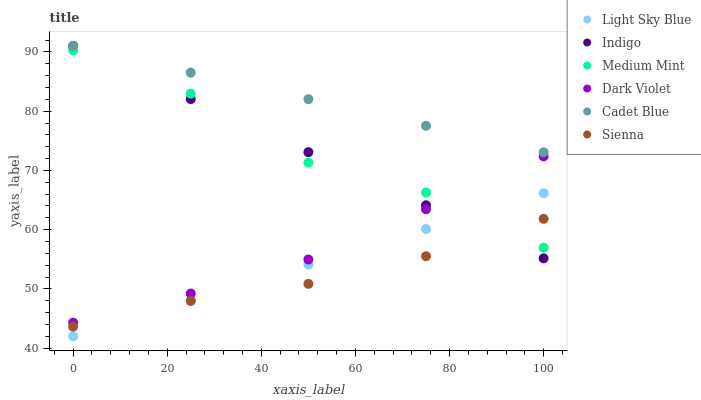Does Sienna have the minimum area under the curve?
Answer yes or no. Yes. Does Cadet Blue have the maximum area under the curve?
Answer yes or no. Yes. Does Indigo have the minimum area under the curve?
Answer yes or no. No. Does Indigo have the maximum area under the curve?
Answer yes or no. No. Is Light Sky Blue the smoothest?
Answer yes or no. Yes. Is Medium Mint the roughest?
Answer yes or no. Yes. Is Cadet Blue the smoothest?
Answer yes or no. No. Is Cadet Blue the roughest?
Answer yes or no. No. Does Light Sky Blue have the lowest value?
Answer yes or no. Yes. Does Indigo have the lowest value?
Answer yes or no. No. Does Indigo have the highest value?
Answer yes or no. Yes. Does Dark Violet have the highest value?
Answer yes or no. No. Is Sienna less than Cadet Blue?
Answer yes or no. Yes. Is Cadet Blue greater than Dark Violet?
Answer yes or no. Yes. Does Medium Mint intersect Indigo?
Answer yes or no. Yes. Is Medium Mint less than Indigo?
Answer yes or no. No. Is Medium Mint greater than Indigo?
Answer yes or no. No. Does Sienna intersect Cadet Blue?
Answer yes or no. No. 